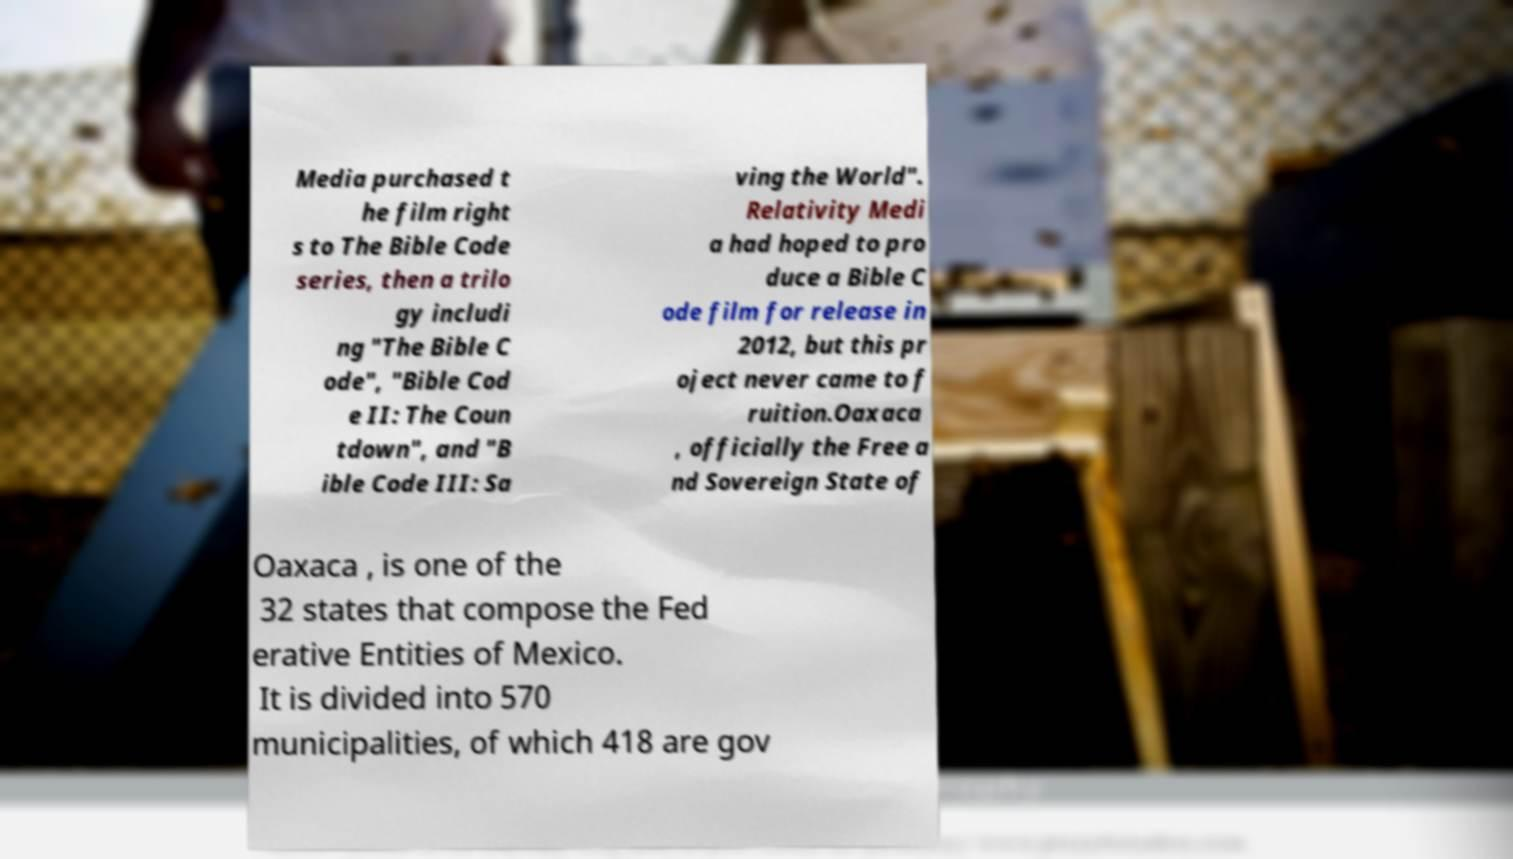Please identify and transcribe the text found in this image. Media purchased t he film right s to The Bible Code series, then a trilo gy includi ng "The Bible C ode", "Bible Cod e II: The Coun tdown", and "B ible Code III: Sa ving the World". Relativity Medi a had hoped to pro duce a Bible C ode film for release in 2012, but this pr oject never came to f ruition.Oaxaca , officially the Free a nd Sovereign State of Oaxaca , is one of the 32 states that compose the Fed erative Entities of Mexico. It is divided into 570 municipalities, of which 418 are gov 